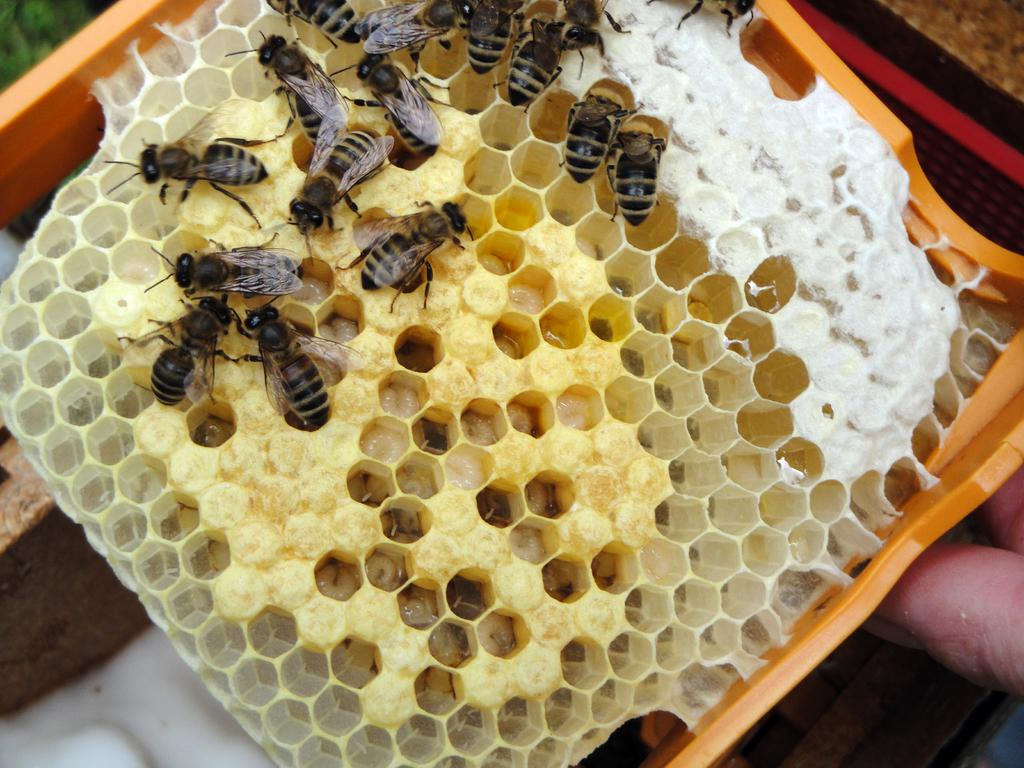What type of insects can be seen in the image? There are honey bees in the image. Where is the honey bee nest located? The honey bee nest is in an object in the image. Can you describe the fingers visible in the image? The fingers of a person are visible in the image. What type of crack can be seen in the image? There is no crack present in the image. What is the honey bee using to sew a needle and thread in the image? Honey bees do not use needles and thread; they collect nectar and pollen. 